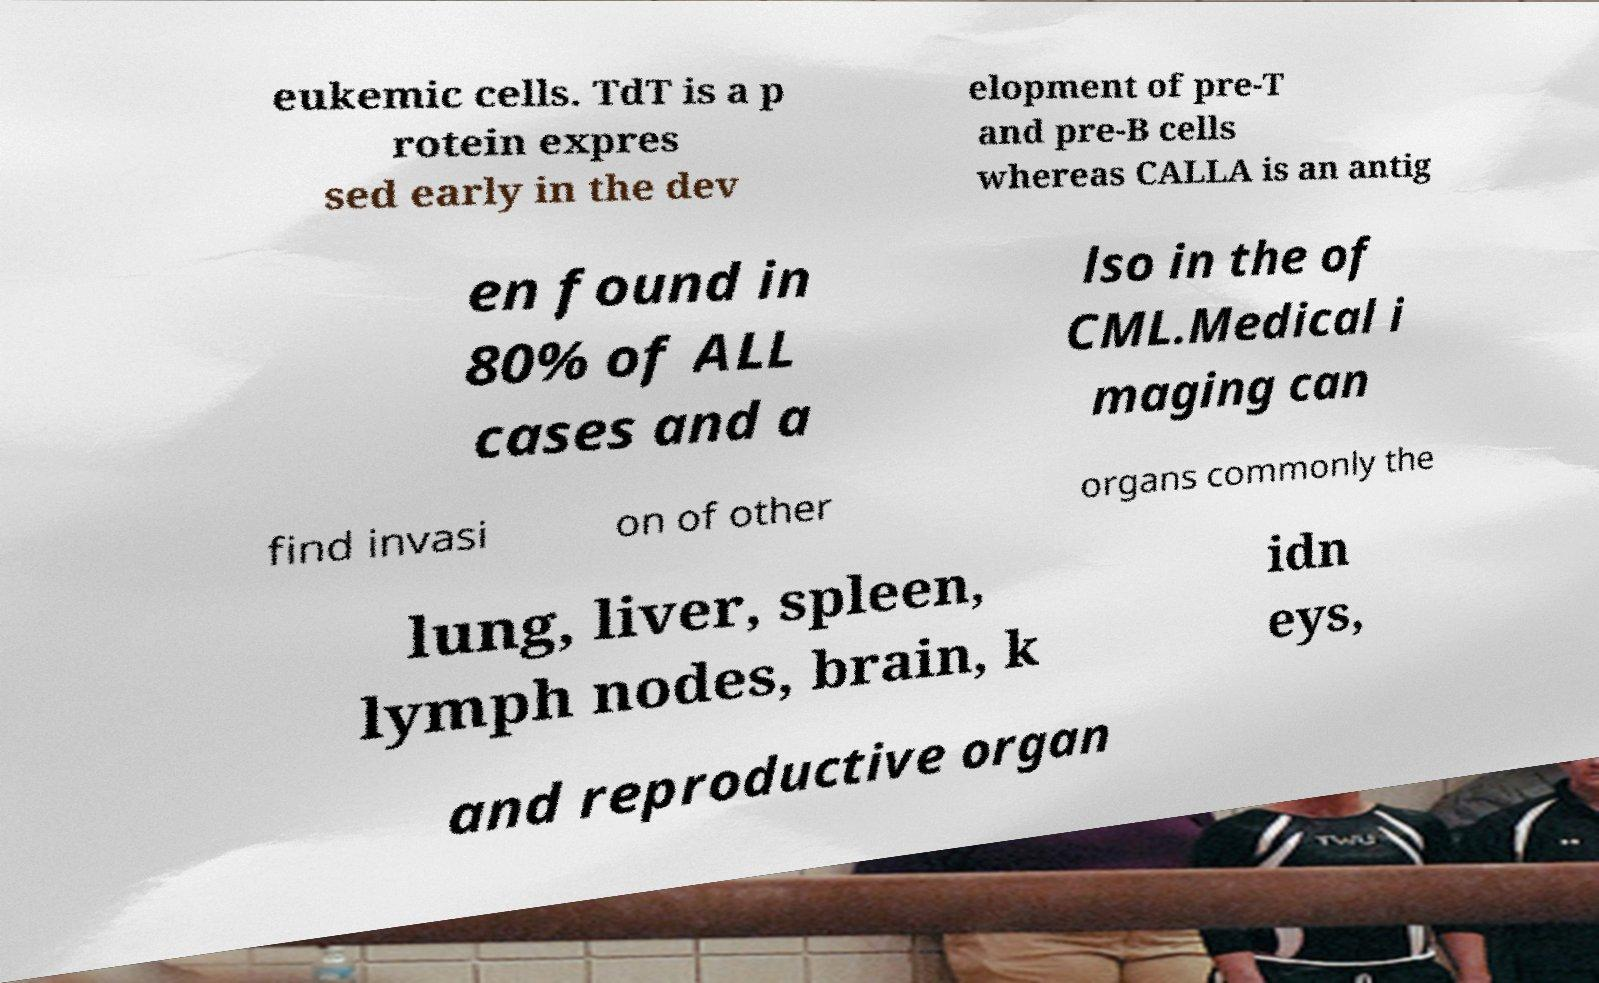I need the written content from this picture converted into text. Can you do that? eukemic cells. TdT is a p rotein expres sed early in the dev elopment of pre-T and pre-B cells whereas CALLA is an antig en found in 80% of ALL cases and a lso in the of CML.Medical i maging can find invasi on of other organs commonly the lung, liver, spleen, lymph nodes, brain, k idn eys, and reproductive organ 